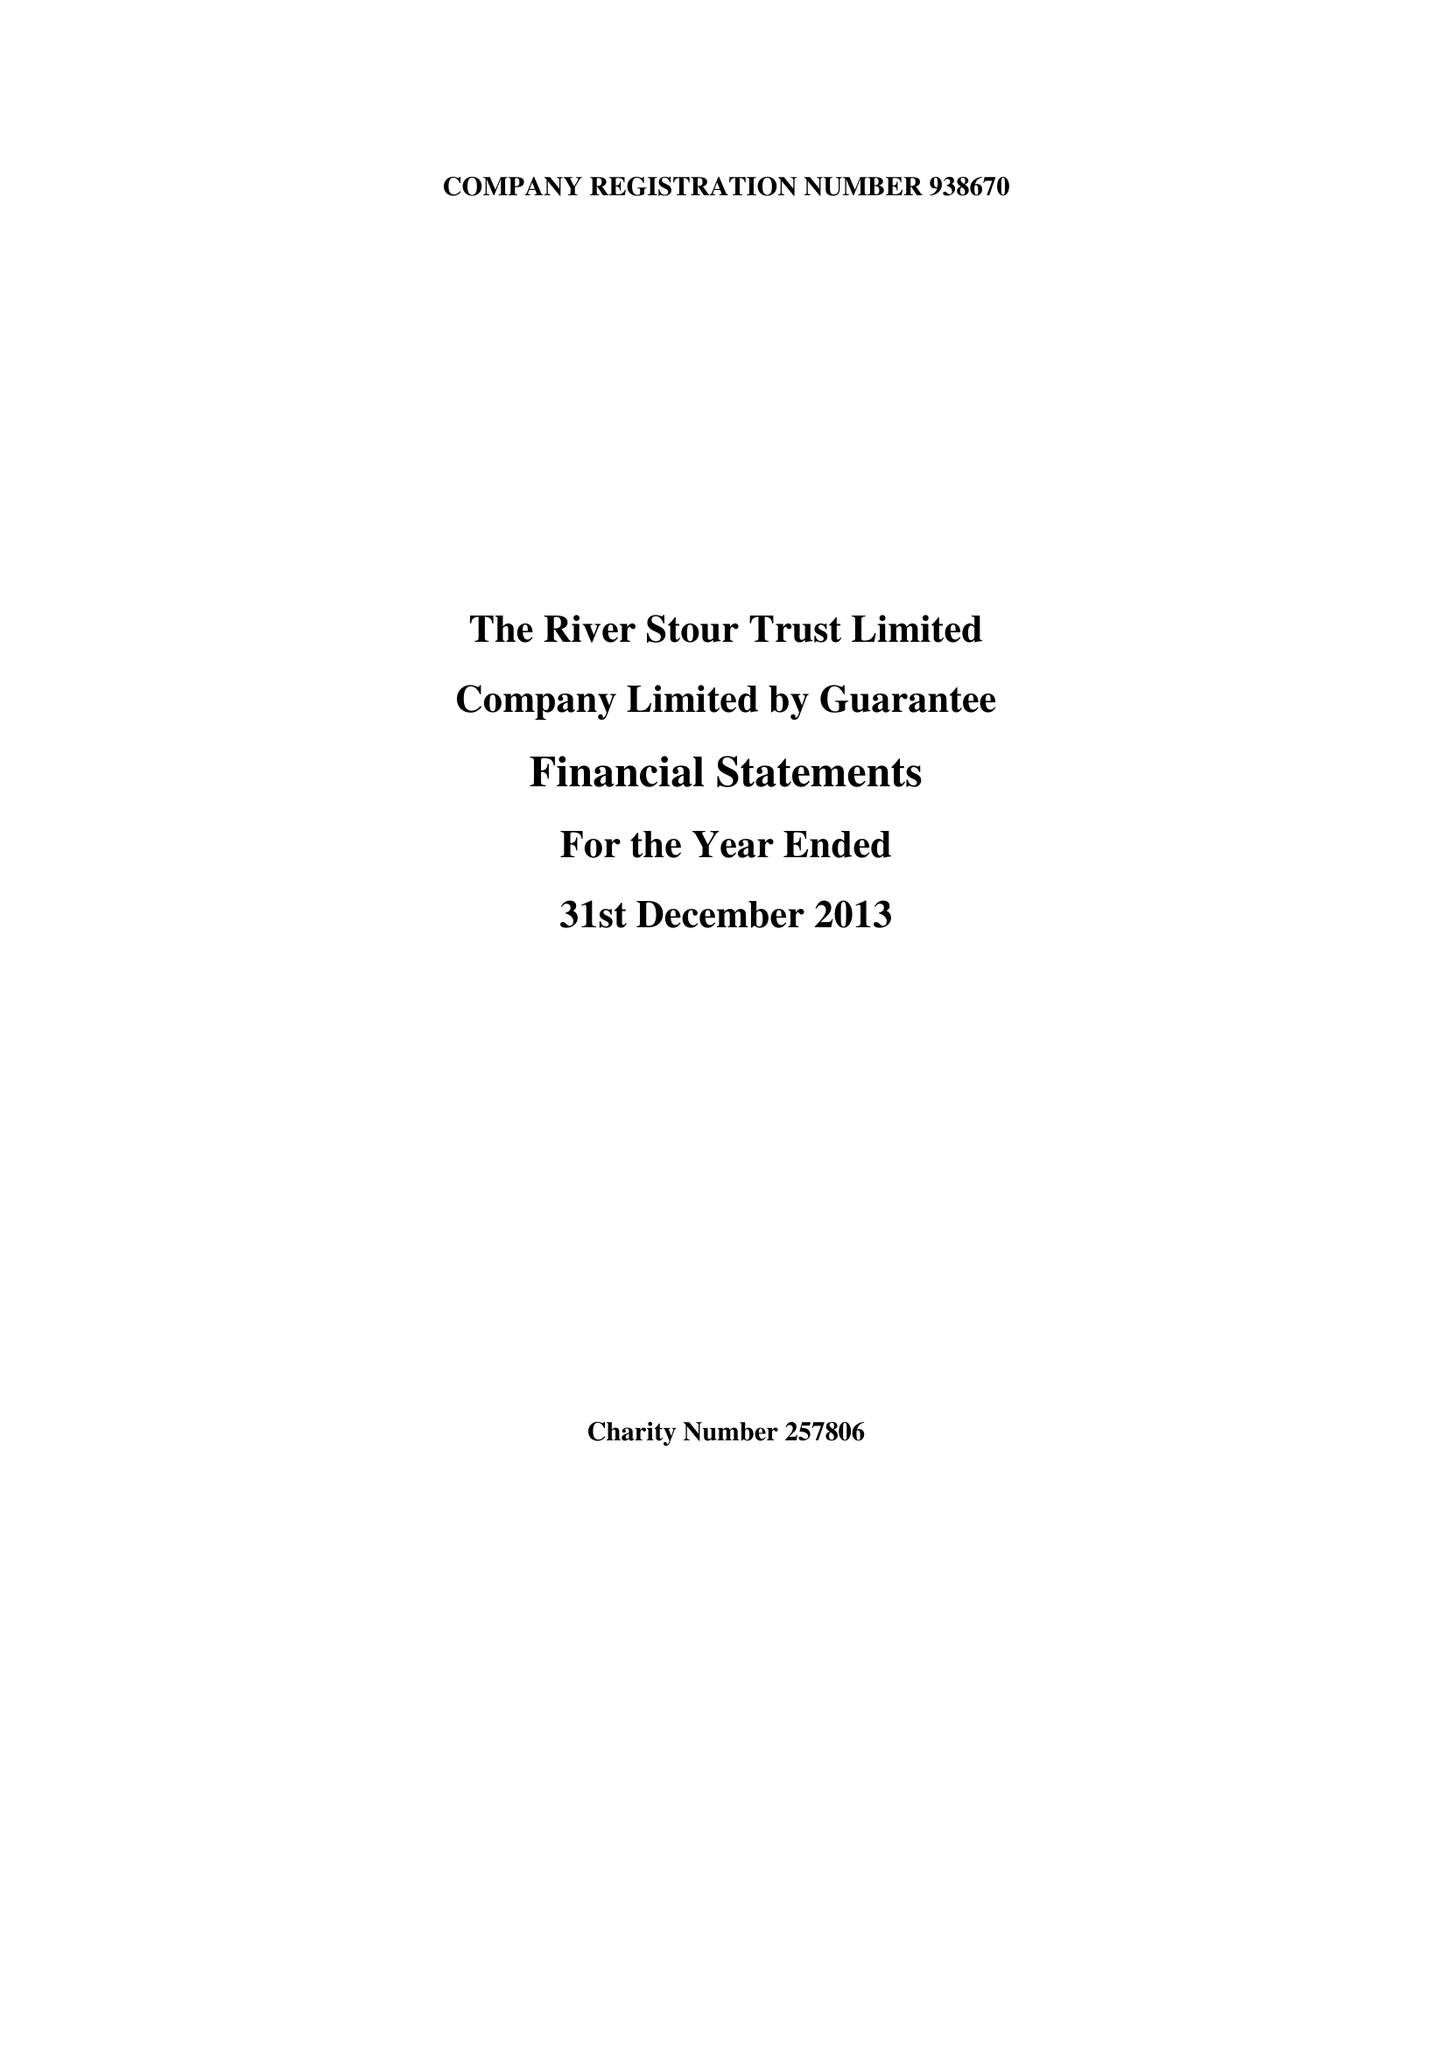What is the value for the address__post_town?
Answer the question using a single word or phrase. SUDBURY 